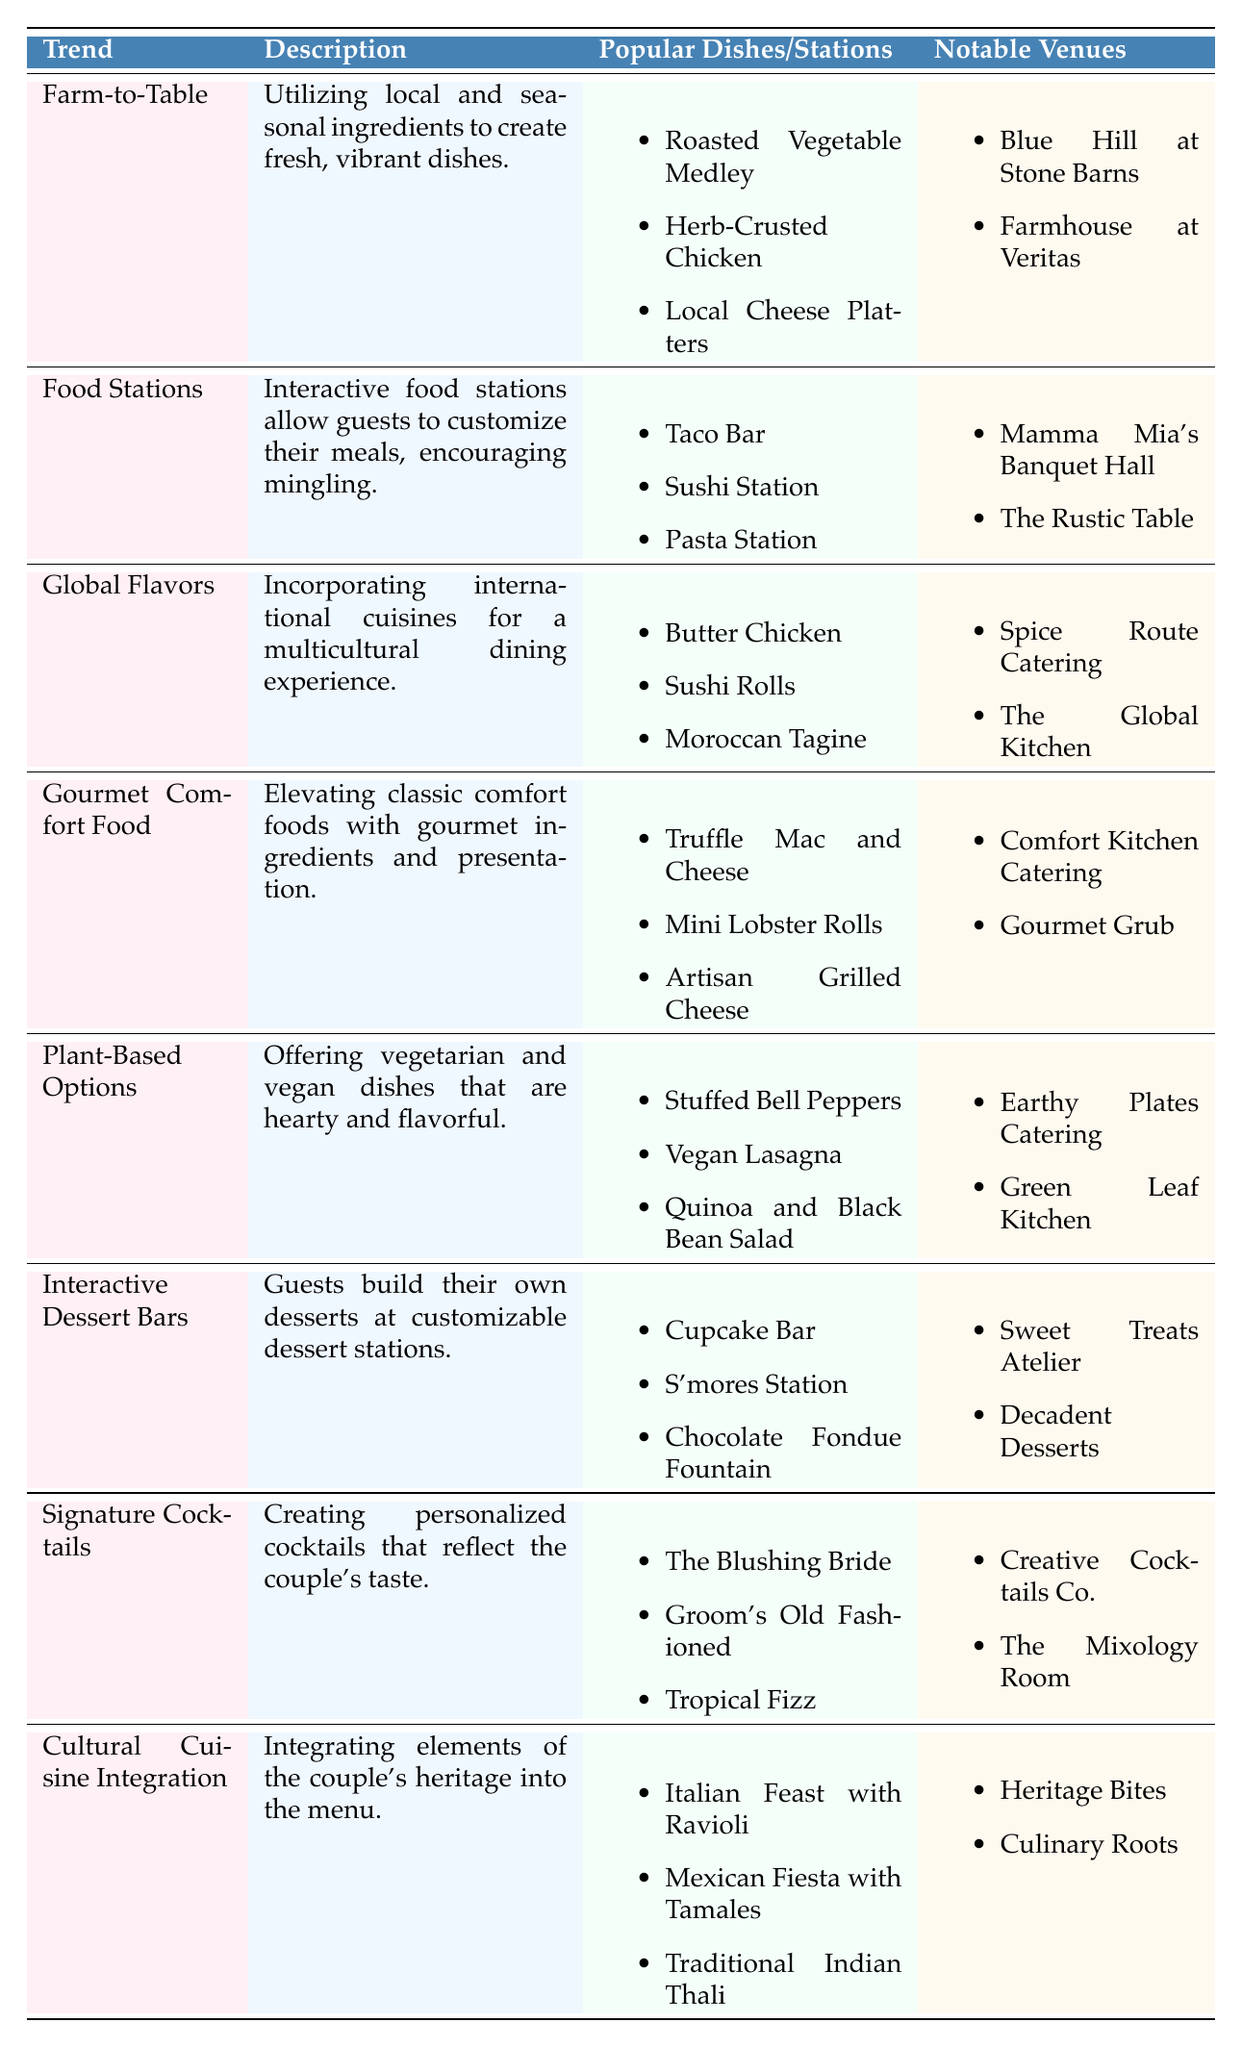What is the trend that focuses on using local and seasonal ingredients? The table lists several trends, and the one that specifically mentions using local and seasonal ingredients is "Farm-to-Table."
Answer: Farm-to-Table Which notable venue is associated with the "Global Flavors" trend? According to the table, the notable venues for the "Global Flavors" trend are "Spice Route Catering" and "The Global Kitchen." Therefore, one of the venues is "Spice Route Catering."
Answer: Spice Route Catering How many different popular dishes are listed under the "Gourmet Comfort Food" trend? The "Gourmet Comfort Food" trend includes three popular dishes: "Truffle Mac and Cheese," "Mini Lobster Rolls," and "Artisan Grilled Cheese." Thus, there are three dishes.
Answer: 3 Is "Vegan Lasagna" a popular dish under the "Plant-Based Options" trend? The table indicates that "Vegan Lasagna" is listed as one of the popular dishes under the "Plant-Based Options" trend, which confirms that the statement is true.
Answer: Yes Which trend includes a customizable dessert station? The trend that features customizable dessert stations is "Interactive Dessert Bars," which explicitly states that guests can build their own desserts.
Answer: Interactive Dessert Bars If you want to incorporate pieces of both Italian and Mexican cuisines, which trend would fit your requirements? The "Cultural Cuisine Integration" trend explicitly mentions integrating elements of the couple's heritage into the menu, allowing for the inclusion of Italian and Mexican dishes. Thus, this trend would be ideal for your requirements.
Answer: Cultural Cuisine Integration How many notable venues are associated with the "Signature Cocktails" trend? The table shows that there are two notable venues associated with the "Signature Cocktails" trend: "Creative Cocktails Co." and "The Mixology Room." Therefore, there are two venues.
Answer: 2 Which trend has a focus on interactive food stations for guest customization? The description of the "Food Stations" trend indicates that it allows guests to customize their meals, focusing on interactivity. Hence, this trend emphasizes this concept.
Answer: Food Stations 